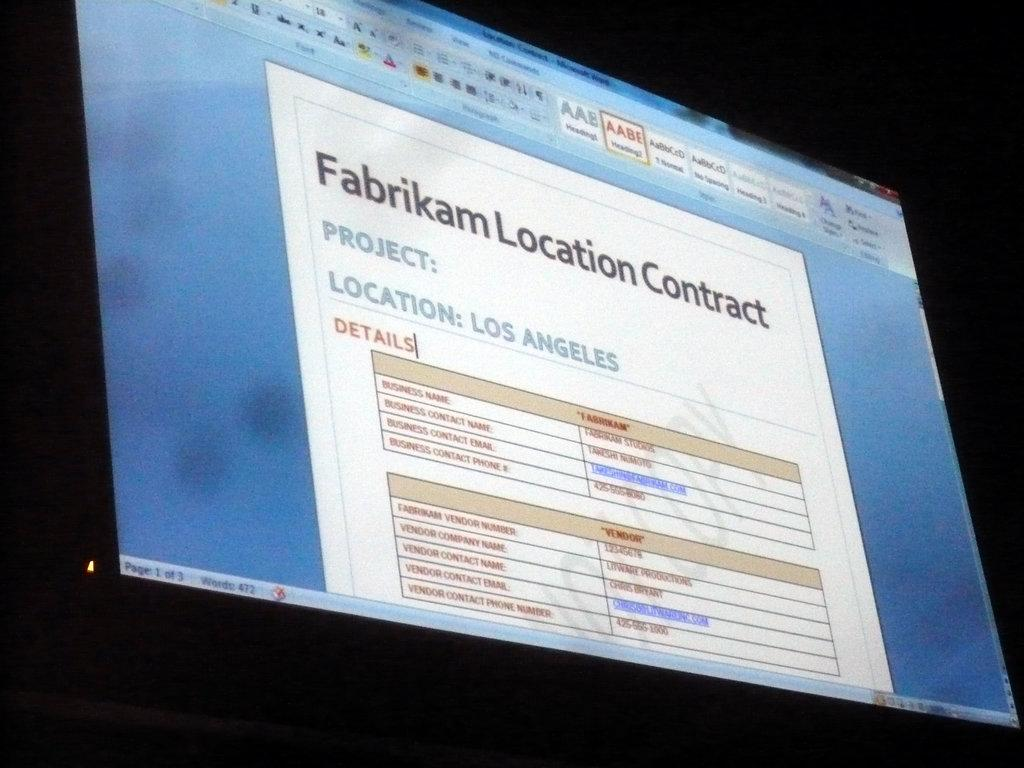<image>
Provide a brief description of the given image. A screen on a computer is titled Fabrikam Location Contract. 